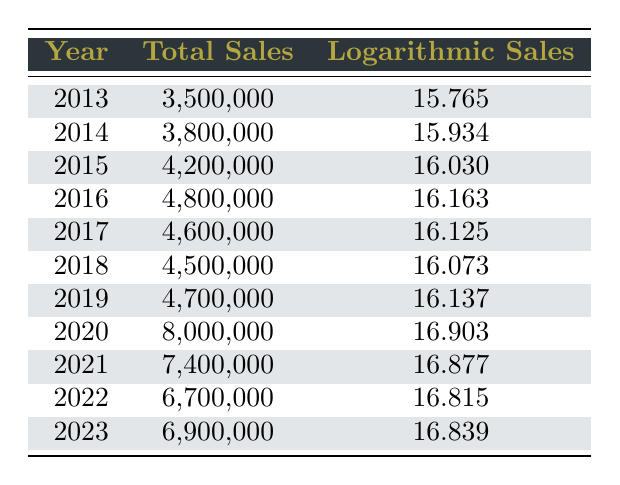What was the total gun sales in 2020? The total gun sales for the year 2020 is listed in the table as 8,000,000.
Answer: 8,000,000 In which year did gun sales peak over the decade? The peak year for gun sales can be identified as 2020 with total sales of 8,000,000.
Answer: 2020 What is the difference in total sales between 2013 and 2015? Total sales for 2013 is 3,500,000 and for 2015 is 4,200,000. The difference is 4,200,000 - 3,500,000 = 700,000.
Answer: 700,000 Did total gun sales increase or decrease from 2019 to 2020? The total gun sales in 2019 was 4,700,000, and in 2020 it increased to 8,000,000, so there was an increase.
Answer: Yes What was the average logarithmic sales from 2017 to 2023? To find the average, we add the logarithmic sales from 2017 to 2023: 16.125 + 16.073 + 16.137 + 16.903 + 16.877 + 16.815 + 16.839 = 113.969. There are 7 values, so the average is 113.969/7 = 16.281.
Answer: 16.281 Which year had the highest logarithmic sales? Looking through the logarithmic sales values, the highest value is 16.903 in the year 2020.
Answer: 2020 What is the total gun sales for the year 2021? The table indicates that the total gun sales for the year 2021 is 7,400,000.
Answer: 7,400,000 How much did total gun sales decrease from 2020 to 2021? Total sales in 2020 was 8,000,000 and in 2021 it was 7,400,000. The decrease is calculated as 8,000,000 - 7,400,000 = 600,000.
Answer: 600,000 